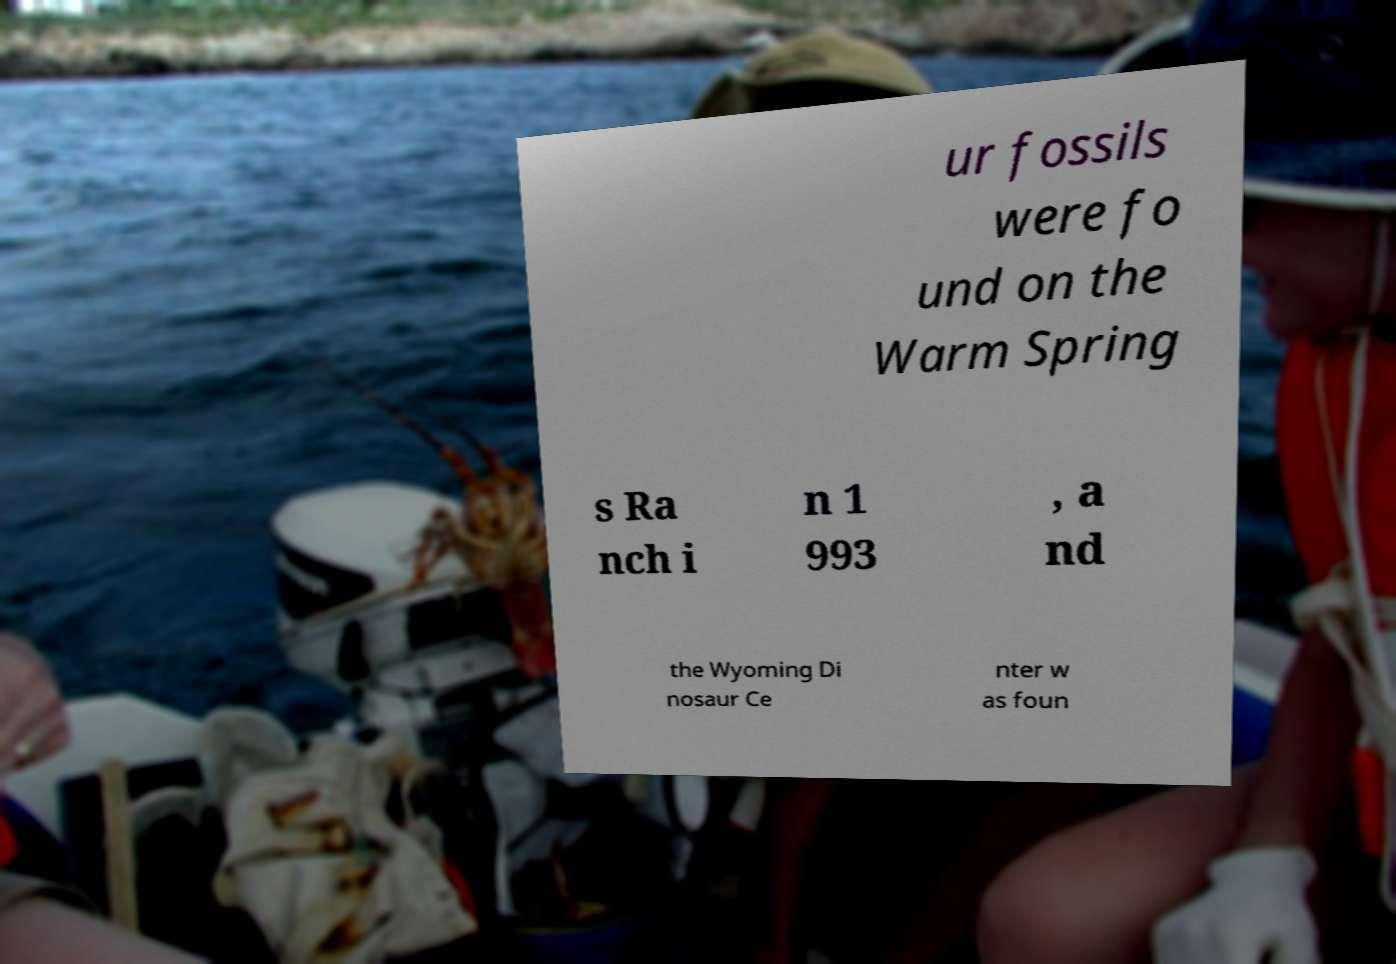Could you extract and type out the text from this image? ur fossils were fo und on the Warm Spring s Ra nch i n 1 993 , a nd the Wyoming Di nosaur Ce nter w as foun 